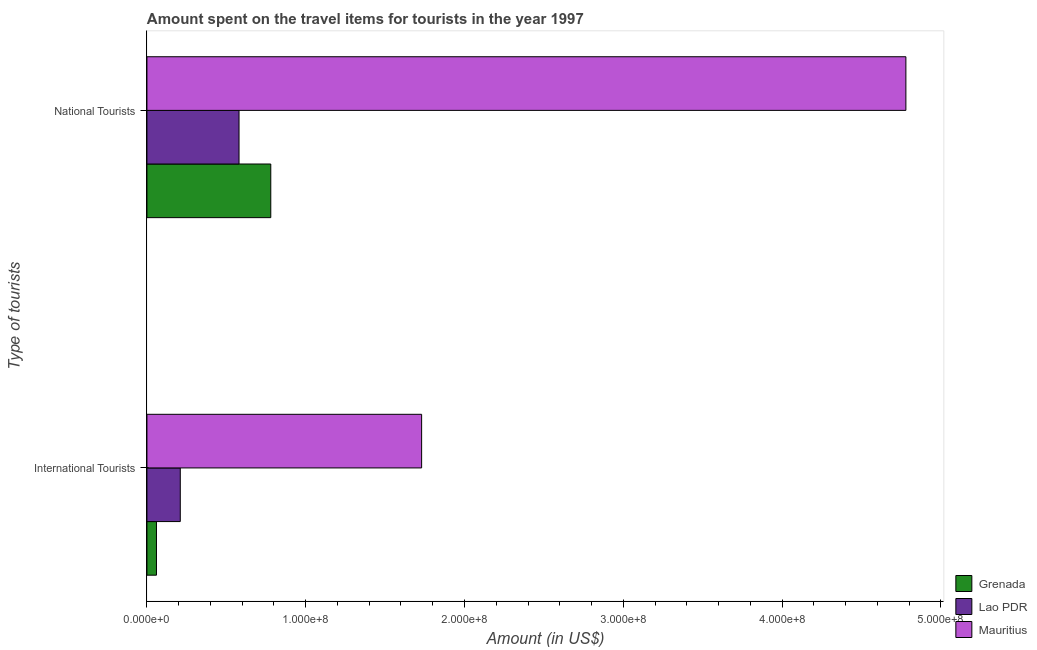How many bars are there on the 2nd tick from the top?
Keep it short and to the point. 3. What is the label of the 2nd group of bars from the top?
Make the answer very short. International Tourists. What is the amount spent on travel items of international tourists in Lao PDR?
Offer a very short reply. 2.10e+07. Across all countries, what is the maximum amount spent on travel items of international tourists?
Your response must be concise. 1.73e+08. Across all countries, what is the minimum amount spent on travel items of international tourists?
Provide a short and direct response. 6.00e+06. In which country was the amount spent on travel items of national tourists maximum?
Make the answer very short. Mauritius. In which country was the amount spent on travel items of national tourists minimum?
Your answer should be compact. Lao PDR. What is the total amount spent on travel items of national tourists in the graph?
Your answer should be compact. 6.14e+08. What is the difference between the amount spent on travel items of international tourists in Lao PDR and that in Mauritius?
Give a very brief answer. -1.52e+08. What is the difference between the amount spent on travel items of national tourists in Mauritius and the amount spent on travel items of international tourists in Grenada?
Offer a very short reply. 4.72e+08. What is the average amount spent on travel items of international tourists per country?
Give a very brief answer. 6.67e+07. What is the difference between the amount spent on travel items of international tourists and amount spent on travel items of national tourists in Grenada?
Give a very brief answer. -7.20e+07. In how many countries, is the amount spent on travel items of national tourists greater than 400000000 US$?
Your answer should be compact. 1. What is the ratio of the amount spent on travel items of national tourists in Lao PDR to that in Grenada?
Your answer should be very brief. 0.74. What does the 2nd bar from the top in National Tourists represents?
Offer a very short reply. Lao PDR. What does the 3rd bar from the bottom in National Tourists represents?
Give a very brief answer. Mauritius. Are all the bars in the graph horizontal?
Provide a short and direct response. Yes. What is the difference between two consecutive major ticks on the X-axis?
Provide a short and direct response. 1.00e+08. Are the values on the major ticks of X-axis written in scientific E-notation?
Offer a terse response. Yes. Does the graph contain any zero values?
Provide a short and direct response. No. Where does the legend appear in the graph?
Offer a terse response. Bottom right. How are the legend labels stacked?
Your response must be concise. Vertical. What is the title of the graph?
Your response must be concise. Amount spent on the travel items for tourists in the year 1997. What is the label or title of the X-axis?
Provide a short and direct response. Amount (in US$). What is the label or title of the Y-axis?
Provide a succinct answer. Type of tourists. What is the Amount (in US$) of Grenada in International Tourists?
Make the answer very short. 6.00e+06. What is the Amount (in US$) in Lao PDR in International Tourists?
Make the answer very short. 2.10e+07. What is the Amount (in US$) of Mauritius in International Tourists?
Offer a terse response. 1.73e+08. What is the Amount (in US$) in Grenada in National Tourists?
Your response must be concise. 7.80e+07. What is the Amount (in US$) in Lao PDR in National Tourists?
Your answer should be very brief. 5.80e+07. What is the Amount (in US$) of Mauritius in National Tourists?
Your answer should be very brief. 4.78e+08. Across all Type of tourists, what is the maximum Amount (in US$) in Grenada?
Offer a terse response. 7.80e+07. Across all Type of tourists, what is the maximum Amount (in US$) in Lao PDR?
Your answer should be very brief. 5.80e+07. Across all Type of tourists, what is the maximum Amount (in US$) in Mauritius?
Make the answer very short. 4.78e+08. Across all Type of tourists, what is the minimum Amount (in US$) in Grenada?
Your response must be concise. 6.00e+06. Across all Type of tourists, what is the minimum Amount (in US$) in Lao PDR?
Keep it short and to the point. 2.10e+07. Across all Type of tourists, what is the minimum Amount (in US$) of Mauritius?
Offer a very short reply. 1.73e+08. What is the total Amount (in US$) in Grenada in the graph?
Provide a succinct answer. 8.40e+07. What is the total Amount (in US$) in Lao PDR in the graph?
Offer a terse response. 7.90e+07. What is the total Amount (in US$) in Mauritius in the graph?
Provide a short and direct response. 6.51e+08. What is the difference between the Amount (in US$) of Grenada in International Tourists and that in National Tourists?
Offer a very short reply. -7.20e+07. What is the difference between the Amount (in US$) of Lao PDR in International Tourists and that in National Tourists?
Offer a terse response. -3.70e+07. What is the difference between the Amount (in US$) in Mauritius in International Tourists and that in National Tourists?
Your answer should be compact. -3.05e+08. What is the difference between the Amount (in US$) of Grenada in International Tourists and the Amount (in US$) of Lao PDR in National Tourists?
Make the answer very short. -5.20e+07. What is the difference between the Amount (in US$) of Grenada in International Tourists and the Amount (in US$) of Mauritius in National Tourists?
Offer a very short reply. -4.72e+08. What is the difference between the Amount (in US$) of Lao PDR in International Tourists and the Amount (in US$) of Mauritius in National Tourists?
Offer a very short reply. -4.57e+08. What is the average Amount (in US$) of Grenada per Type of tourists?
Provide a succinct answer. 4.20e+07. What is the average Amount (in US$) in Lao PDR per Type of tourists?
Ensure brevity in your answer.  3.95e+07. What is the average Amount (in US$) in Mauritius per Type of tourists?
Ensure brevity in your answer.  3.26e+08. What is the difference between the Amount (in US$) in Grenada and Amount (in US$) in Lao PDR in International Tourists?
Give a very brief answer. -1.50e+07. What is the difference between the Amount (in US$) in Grenada and Amount (in US$) in Mauritius in International Tourists?
Offer a terse response. -1.67e+08. What is the difference between the Amount (in US$) of Lao PDR and Amount (in US$) of Mauritius in International Tourists?
Give a very brief answer. -1.52e+08. What is the difference between the Amount (in US$) in Grenada and Amount (in US$) in Mauritius in National Tourists?
Your answer should be compact. -4.00e+08. What is the difference between the Amount (in US$) of Lao PDR and Amount (in US$) of Mauritius in National Tourists?
Your answer should be compact. -4.20e+08. What is the ratio of the Amount (in US$) in Grenada in International Tourists to that in National Tourists?
Ensure brevity in your answer.  0.08. What is the ratio of the Amount (in US$) of Lao PDR in International Tourists to that in National Tourists?
Keep it short and to the point. 0.36. What is the ratio of the Amount (in US$) in Mauritius in International Tourists to that in National Tourists?
Your response must be concise. 0.36. What is the difference between the highest and the second highest Amount (in US$) of Grenada?
Offer a very short reply. 7.20e+07. What is the difference between the highest and the second highest Amount (in US$) in Lao PDR?
Ensure brevity in your answer.  3.70e+07. What is the difference between the highest and the second highest Amount (in US$) of Mauritius?
Your answer should be very brief. 3.05e+08. What is the difference between the highest and the lowest Amount (in US$) of Grenada?
Your response must be concise. 7.20e+07. What is the difference between the highest and the lowest Amount (in US$) of Lao PDR?
Offer a terse response. 3.70e+07. What is the difference between the highest and the lowest Amount (in US$) of Mauritius?
Your response must be concise. 3.05e+08. 